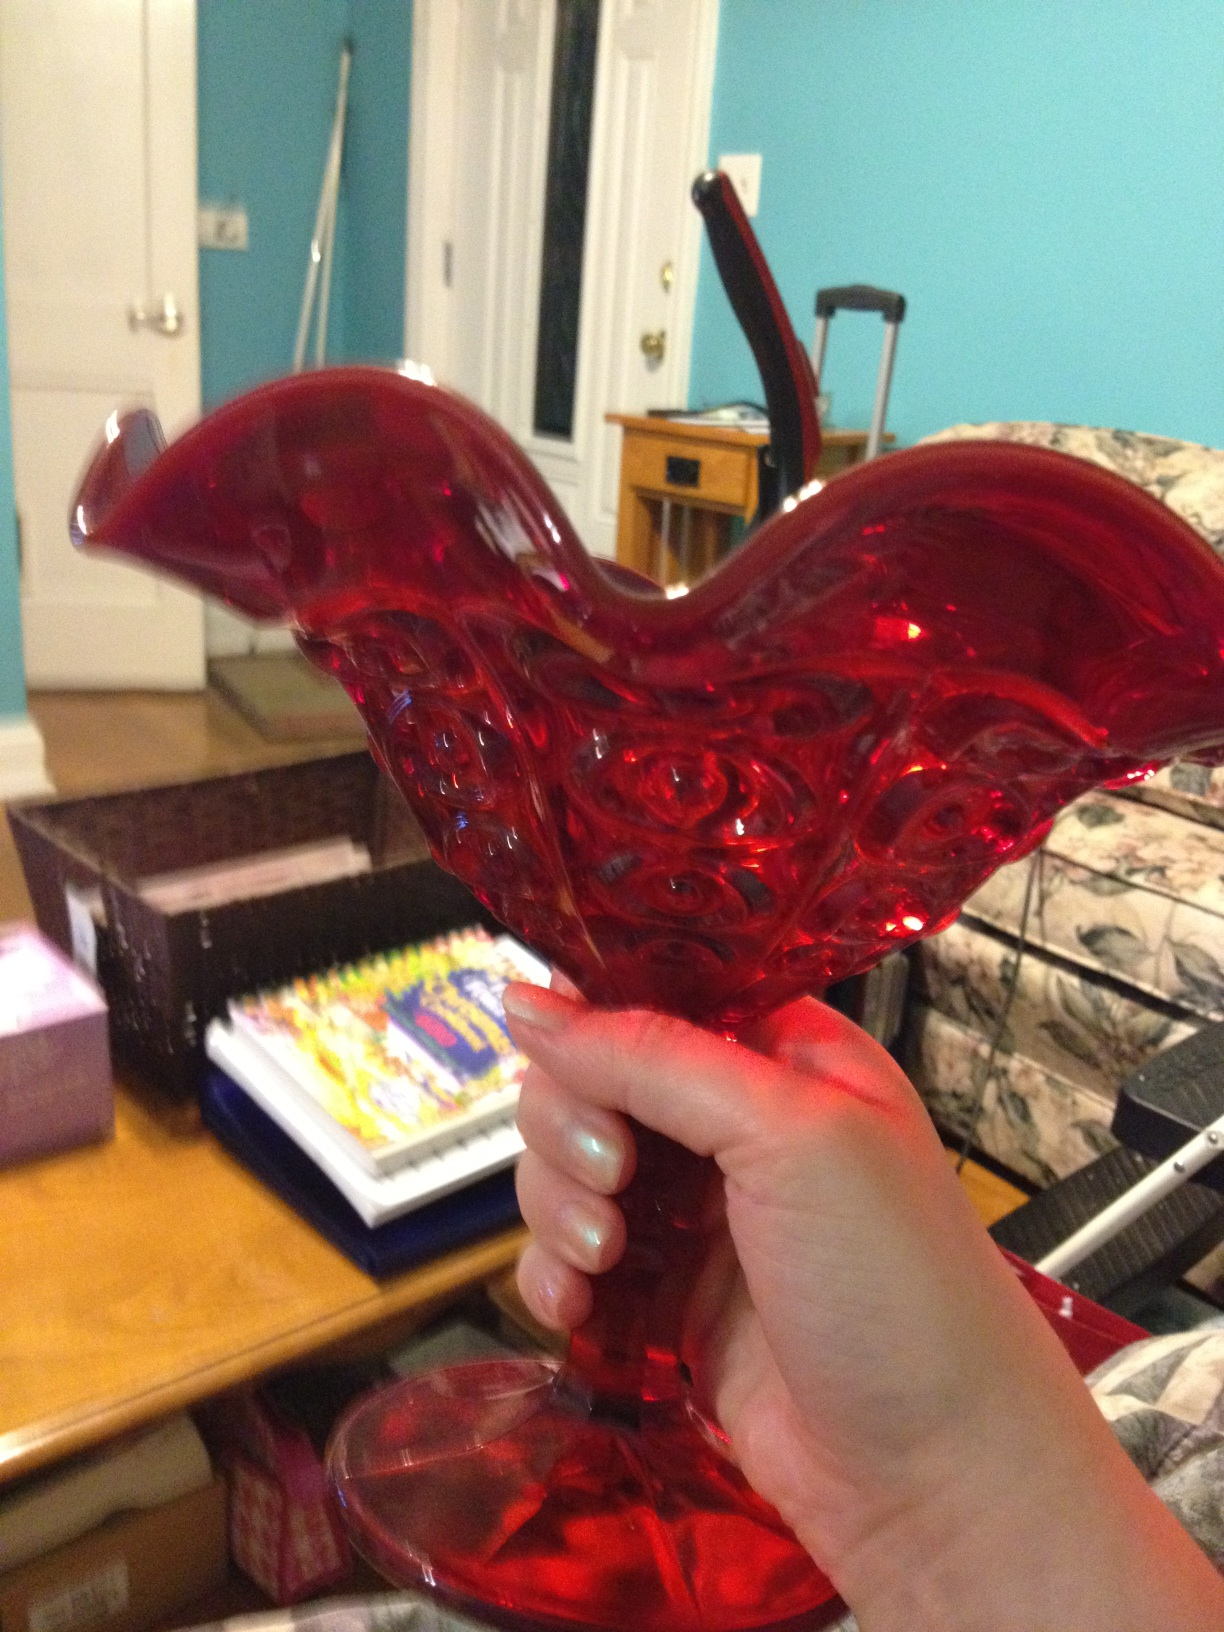Can you describe the details and craftsmanship of this object? The vase is crafted from a vibrant red glass, showcasing a meticulous and artistic design. The scalloped edges add a touch of elegance, while the intricate patterns along its body highlight the skill and precision put into its creation. The sturdy base ensures stability, making it not only an aesthetically pleasing item but also a functional one. What might be the historical or cultural significance of an item like this? Glass vases like this often carry significant historical and cultural value. In many cultures, such intricately designed glassware is associated with artistry and craftsmanship, often passed down through generations as cherished heirlooms. The red color is symbolic in various traditions, representing emotions ranging from love and passion to prosperity and good fortune. Collecting or gifting these vases can be a way of preserving cultural heritage and appreciating fine art. 